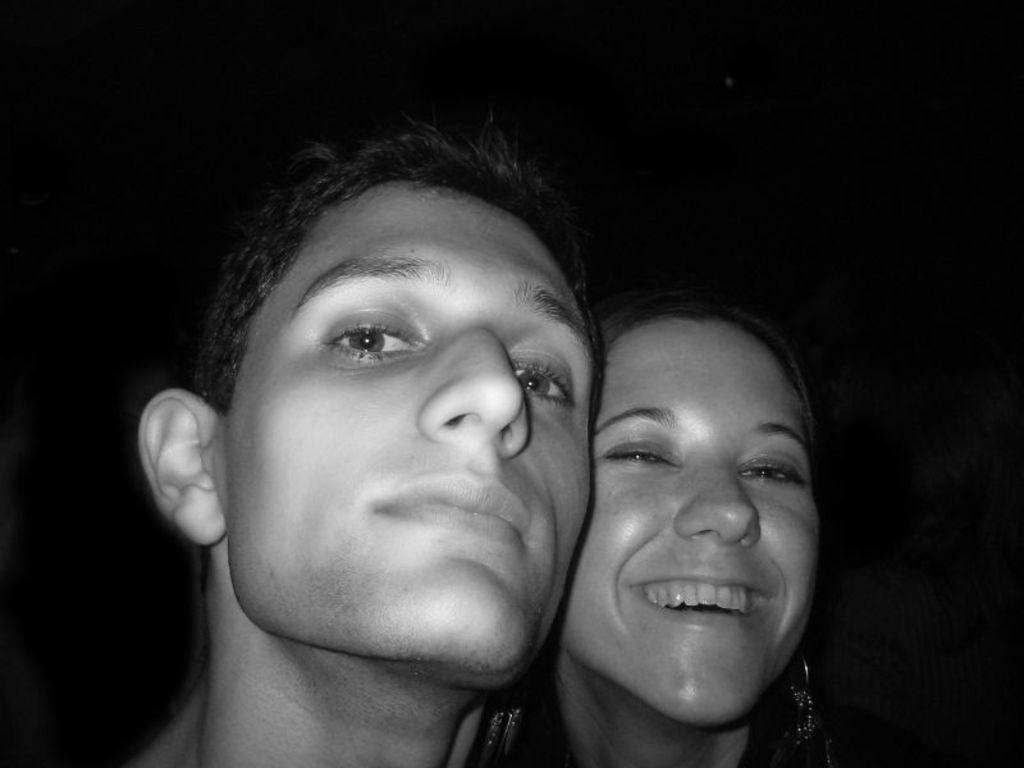What is the color scheme of the image? The image is black and white. How many people are present in the image? There are two persons in the image. What type of creature can be seen wearing underwear in the image? There is no creature or underwear present in the image; it features two persons in a black and white setting. 